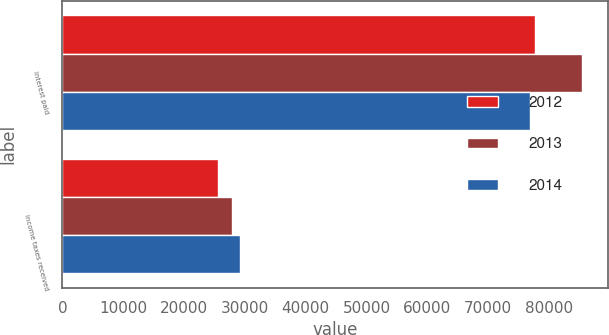Convert chart to OTSL. <chart><loc_0><loc_0><loc_500><loc_500><stacked_bar_chart><ecel><fcel>Interest paid<fcel>Income taxes received<nl><fcel>2012<fcel>77663<fcel>25581<nl><fcel>2013<fcel>85443<fcel>27820<nl><fcel>2014<fcel>76833<fcel>29251<nl></chart> 